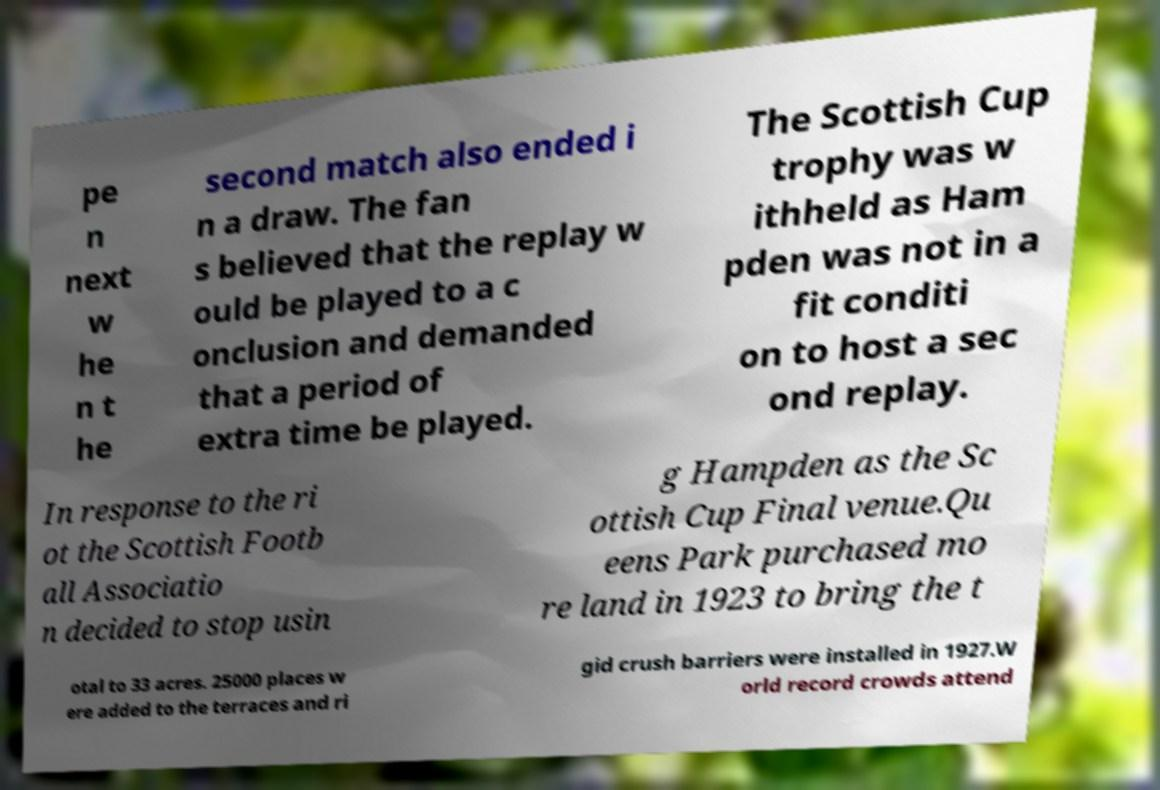Please identify and transcribe the text found in this image. pe n next w he n t he second match also ended i n a draw. The fan s believed that the replay w ould be played to a c onclusion and demanded that a period of extra time be played. The Scottish Cup trophy was w ithheld as Ham pden was not in a fit conditi on to host a sec ond replay. In response to the ri ot the Scottish Footb all Associatio n decided to stop usin g Hampden as the Sc ottish Cup Final venue.Qu eens Park purchased mo re land in 1923 to bring the t otal to 33 acres. 25000 places w ere added to the terraces and ri gid crush barriers were installed in 1927.W orld record crowds attend 